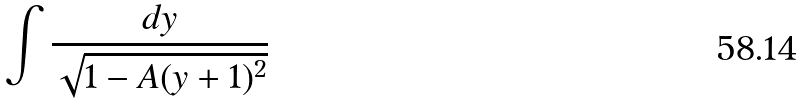Convert formula to latex. <formula><loc_0><loc_0><loc_500><loc_500>\int \frac { d y } { \sqrt { 1 - A ( y + 1 ) ^ { 2 } } }</formula> 